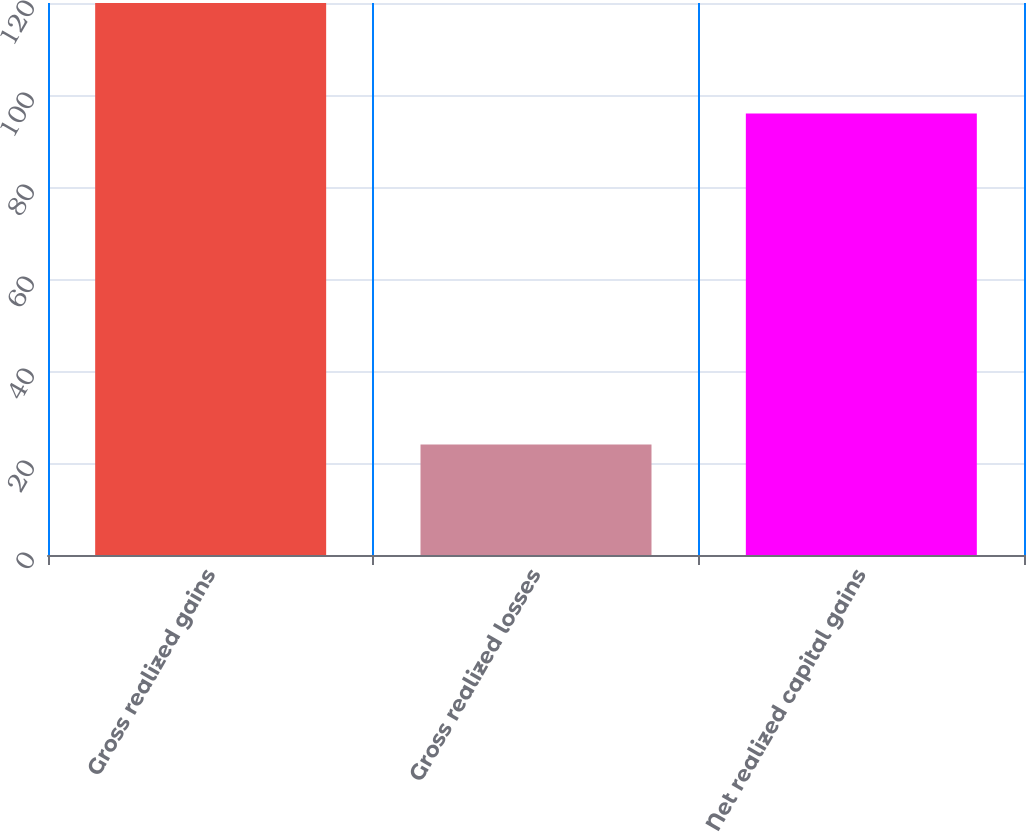Convert chart. <chart><loc_0><loc_0><loc_500><loc_500><bar_chart><fcel>Gross realized gains<fcel>Gross realized losses<fcel>Net realized capital gains<nl><fcel>120<fcel>24<fcel>96<nl></chart> 